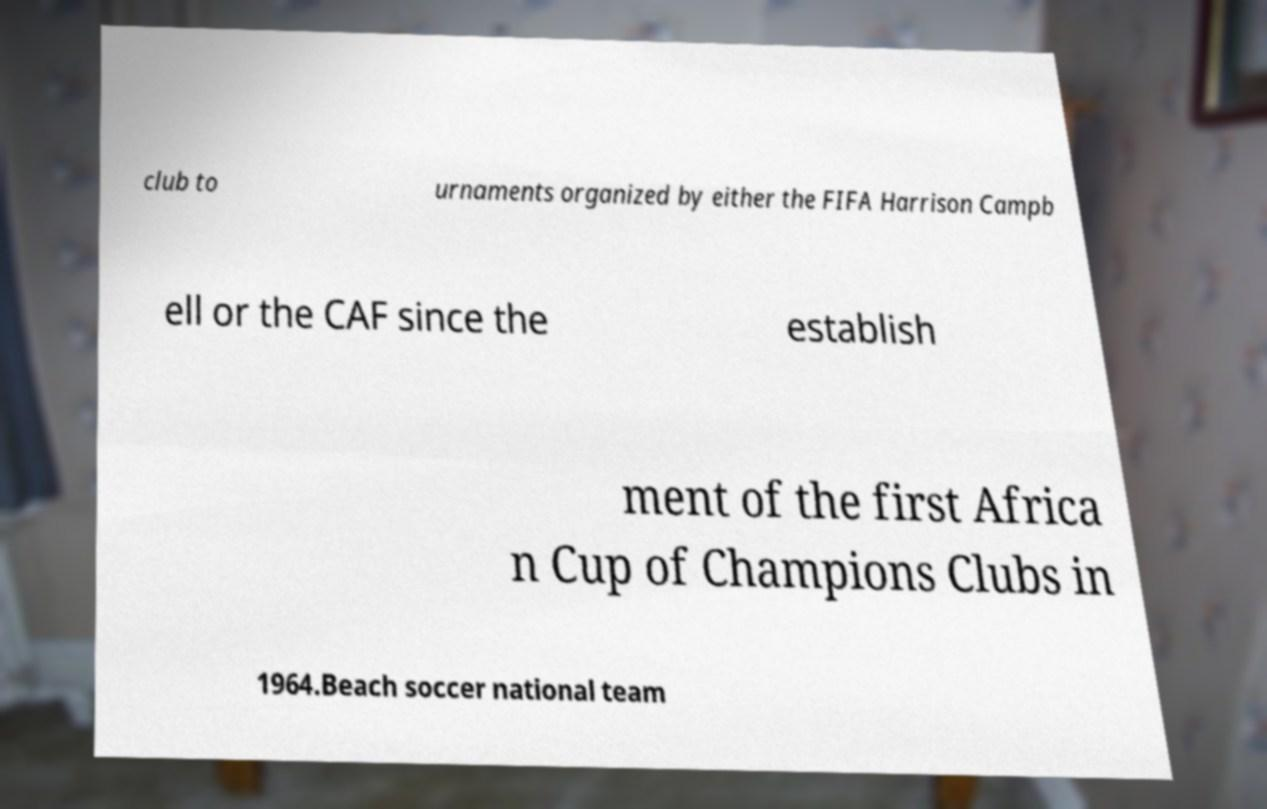Can you read and provide the text displayed in the image?This photo seems to have some interesting text. Can you extract and type it out for me? club to urnaments organized by either the FIFA Harrison Campb ell or the CAF since the establish ment of the first Africa n Cup of Champions Clubs in 1964.Beach soccer national team 